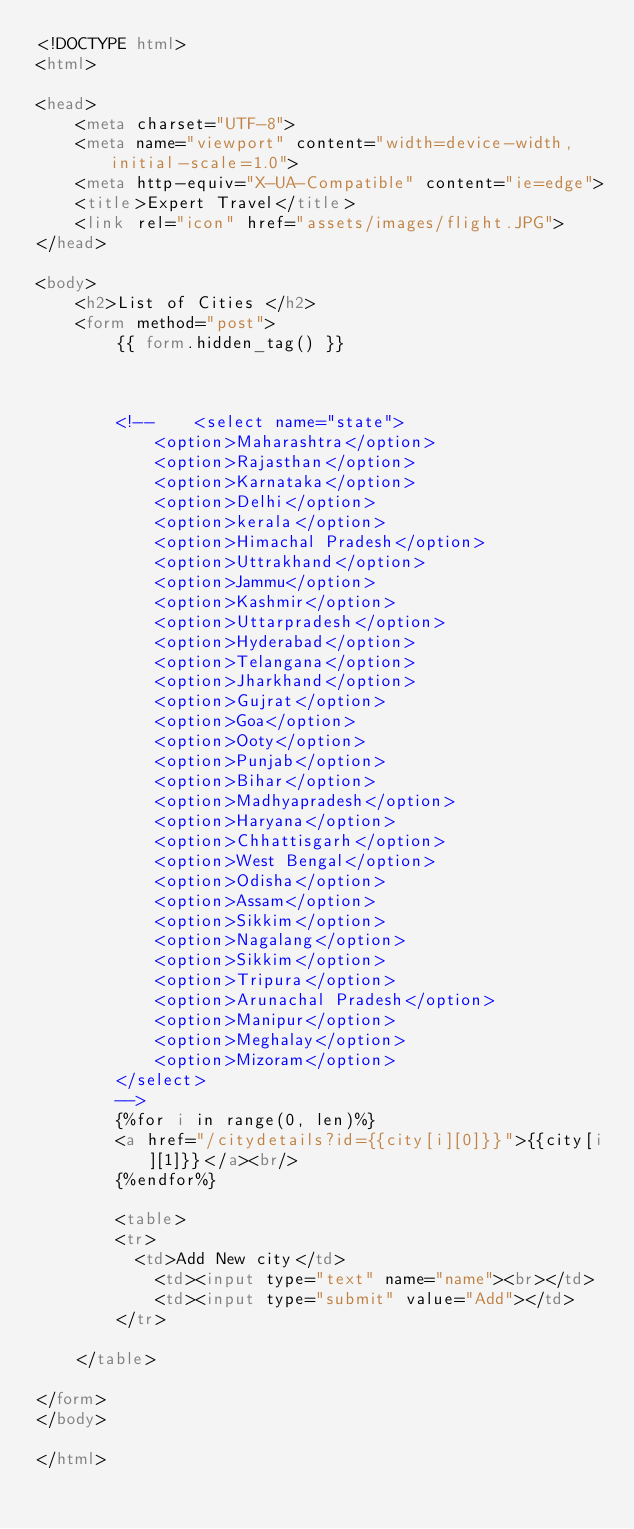Convert code to text. <code><loc_0><loc_0><loc_500><loc_500><_HTML_><!DOCTYPE html>
<html>

<head>
	<meta charset="UTF-8">
	<meta name="viewport" content="width=device-width, initial-scale=1.0">
	<meta http-equiv="X-UA-Compatible" content="ie=edge">
	<title>Expert Travel</title>
    <link rel="icon" href="assets/images/flight.JPG">
</head>

<body>
	<h2>List of Cities </h2>
	<form method="post">
		{{ form.hidden_tag() }}
	
		

		<!-- 	<select name="state">
			<option>Maharashtra</option>
			<option>Rajasthan</option>
			<option>Karnataka</option>
			<option>Delhi</option>
			<option>kerala</option>
			<option>Himachal Pradesh</option>
			<option>Uttrakhand</option>
			<option>Jammu</option>
			<option>Kashmir</option>
			<option>Uttarpradesh</option>
			<option>Hyderabad</option>
			<option>Telangana</option>
			<option>Jharkhand</option>
			<option>Gujrat</option>
			<option>Goa</option>
			<option>Ooty</option>
			<option>Punjab</option>
			<option>Bihar</option>
			<option>Madhyapradesh</option>
			<option>Haryana</option>
			<option>Chhattisgarh</option>
			<option>West Bengal</option>
			<option>Odisha</option>
			<option>Assam</option>
			<option>Sikkim</option>
			<option>Nagalang</option>
			<option>Sikkim</option>
			<option>Tripura</option>
			<option>Arunachal Pradesh</option>
			<option>Manipur</option>
			<option>Meghalay</option>
			<option>Mizoram</option>
		</select>
		-->
		{%for i in range(0, len)%}
		<a href="/citydetails?id={{city[i][0]}}">{{city[i][1]}}</a><br/>
		{%endfor%}
         
		<table>
		<tr>
		  <td>Add New city</td> 
			<td><input type="text" name="name"><br></td>
			<td><input type="submit" value="Add"></td>
		</tr>
		
	</table>
		
</form>
</body>

</html></code> 